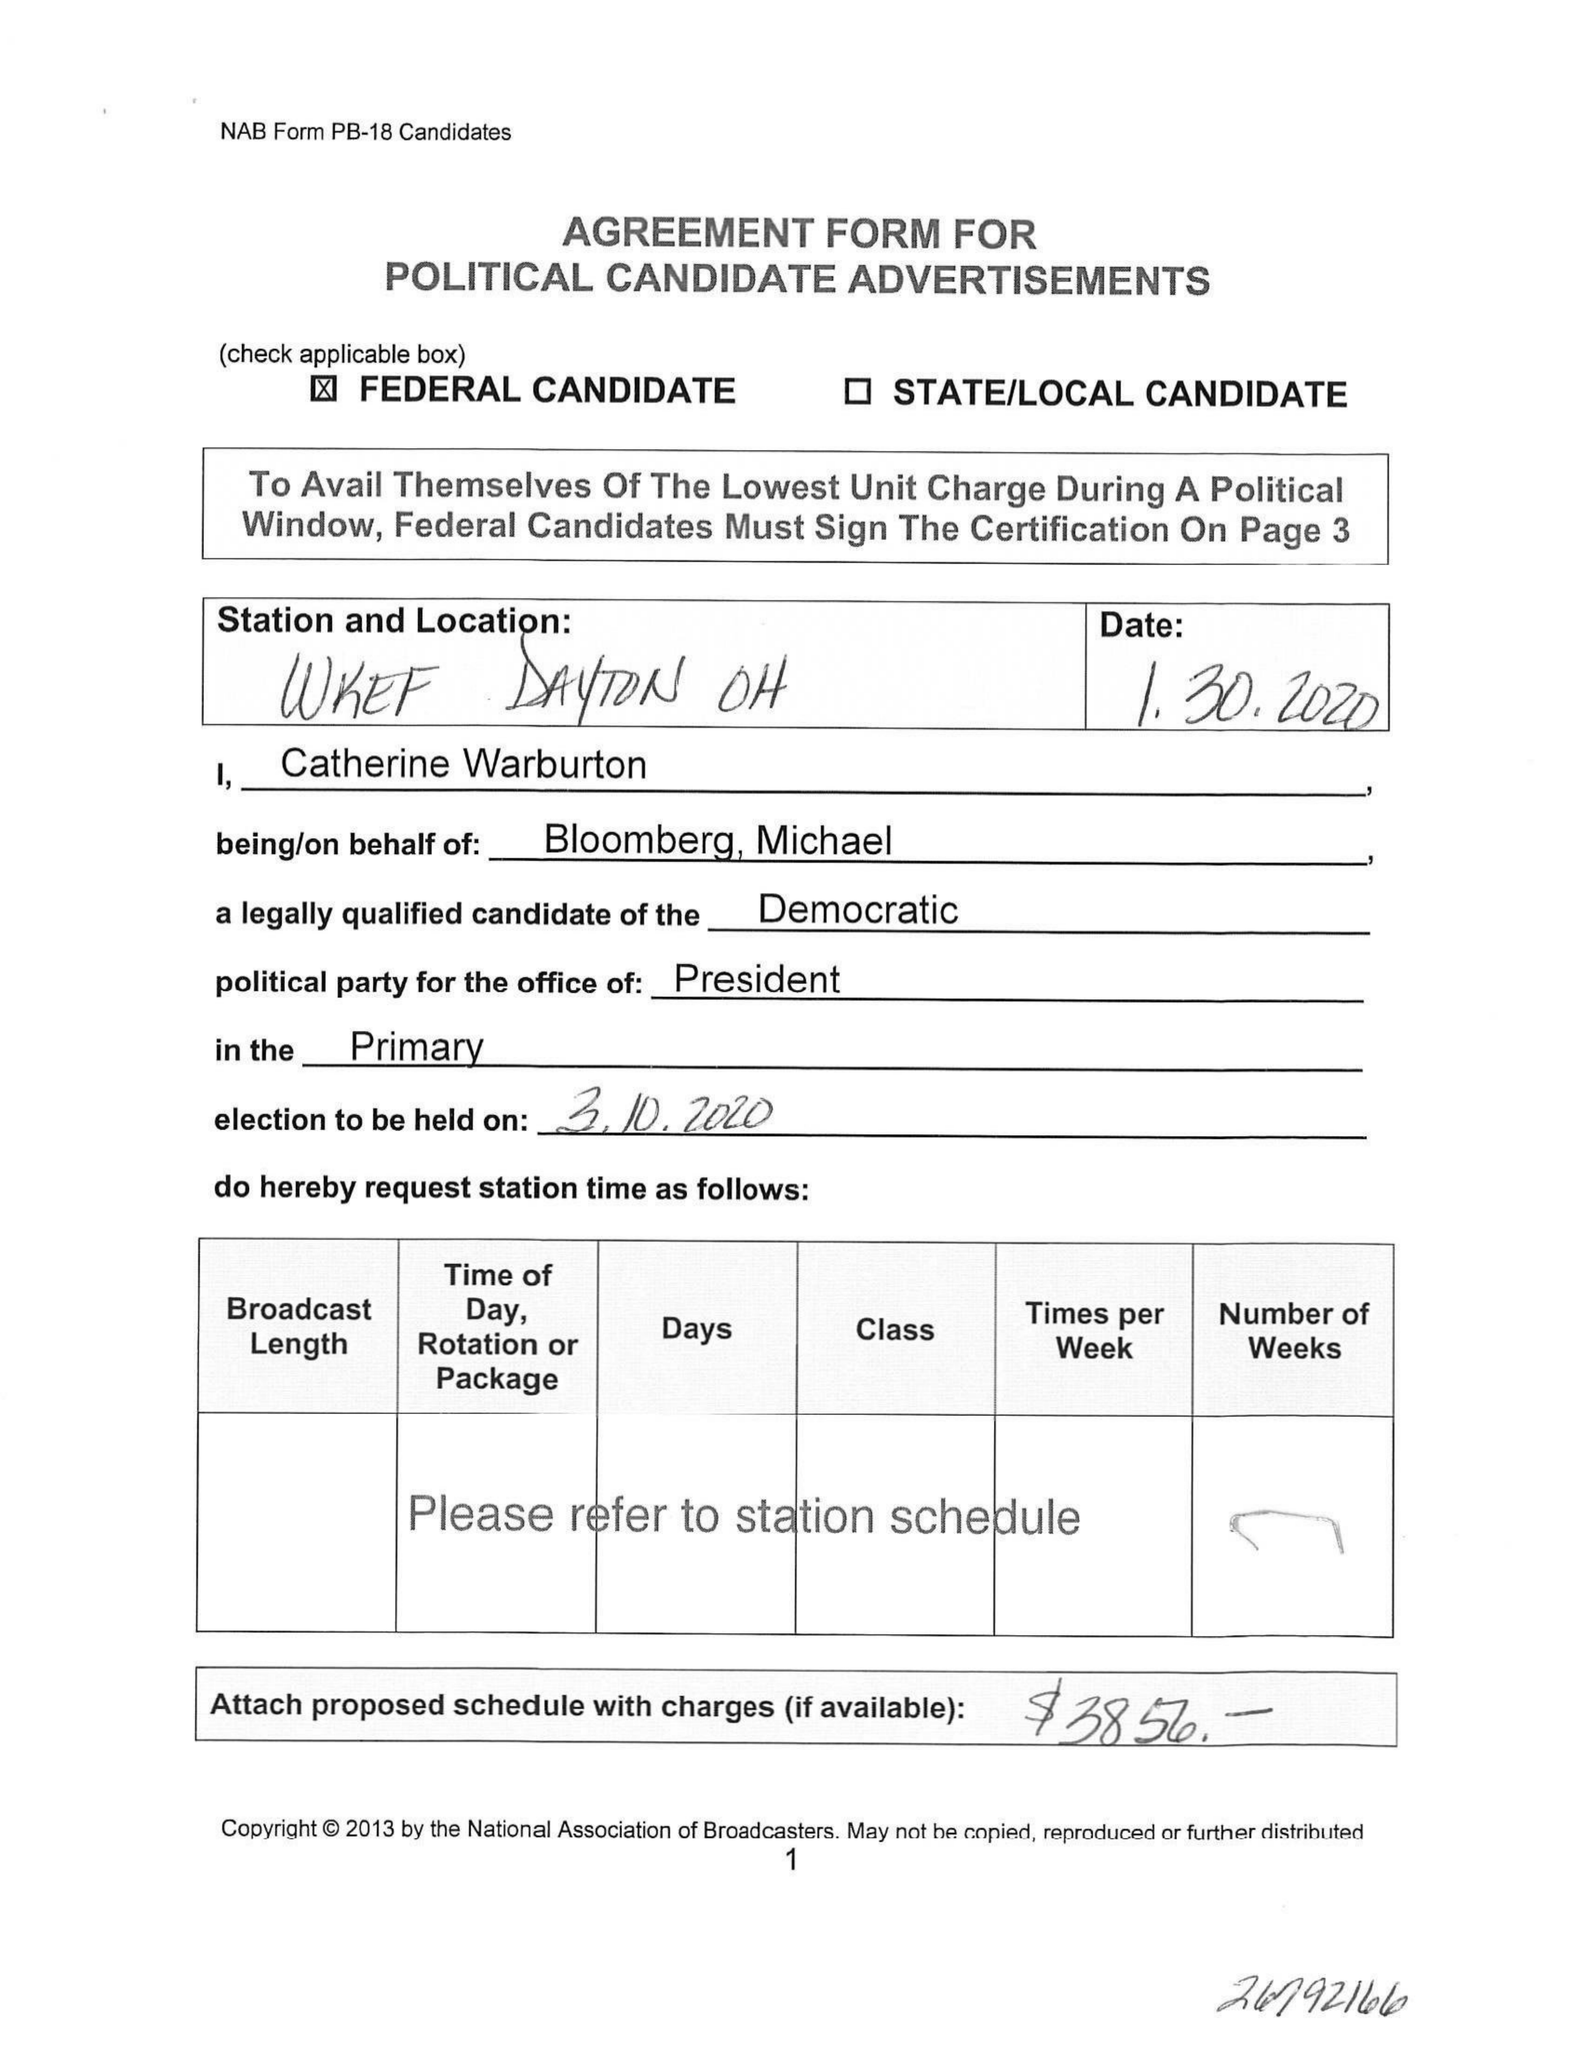What is the value for the flight_to?
Answer the question using a single word or phrase. None 